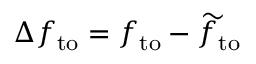<formula> <loc_0><loc_0><loc_500><loc_500>\Delta f _ { t o } = f _ { t o } - \widetilde { f } _ { t o }</formula> 